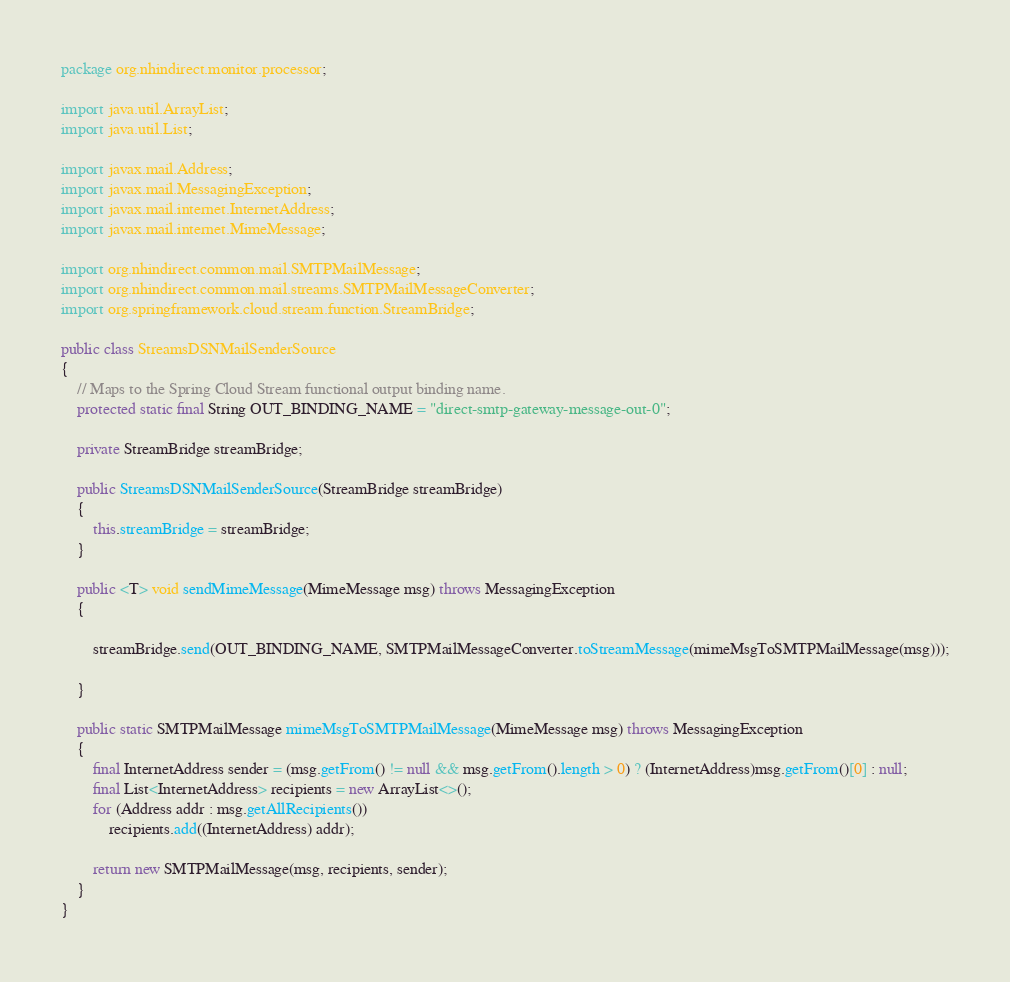Convert code to text. <code><loc_0><loc_0><loc_500><loc_500><_Java_>package org.nhindirect.monitor.processor;

import java.util.ArrayList;
import java.util.List;

import javax.mail.Address;
import javax.mail.MessagingException;
import javax.mail.internet.InternetAddress;
import javax.mail.internet.MimeMessage;

import org.nhindirect.common.mail.SMTPMailMessage;
import org.nhindirect.common.mail.streams.SMTPMailMessageConverter;
import org.springframework.cloud.stream.function.StreamBridge;

public class StreamsDSNMailSenderSource 
{
	// Maps to the Spring Cloud Stream functional output binding name.
	protected static final String OUT_BINDING_NAME = "direct-smtp-gateway-message-out-0";
	
	private StreamBridge streamBridge;
	
	public StreamsDSNMailSenderSource(StreamBridge streamBridge)
	{
		this.streamBridge = streamBridge;
	}
	
	public <T> void sendMimeMessage(MimeMessage msg) throws MessagingException
	{

		streamBridge.send(OUT_BINDING_NAME, SMTPMailMessageConverter.toStreamMessage(mimeMsgToSMTPMailMessage(msg)));

	}

	public static SMTPMailMessage mimeMsgToSMTPMailMessage(MimeMessage msg) throws MessagingException
	{
		final InternetAddress sender = (msg.getFrom() != null && msg.getFrom().length > 0) ? (InternetAddress)msg.getFrom()[0] : null;
		final List<InternetAddress> recipients = new ArrayList<>(); 
		for (Address addr : msg.getAllRecipients())
			recipients.add((InternetAddress) addr);
		
		return new SMTPMailMessage(msg, recipients, sender);
	}
}
</code> 